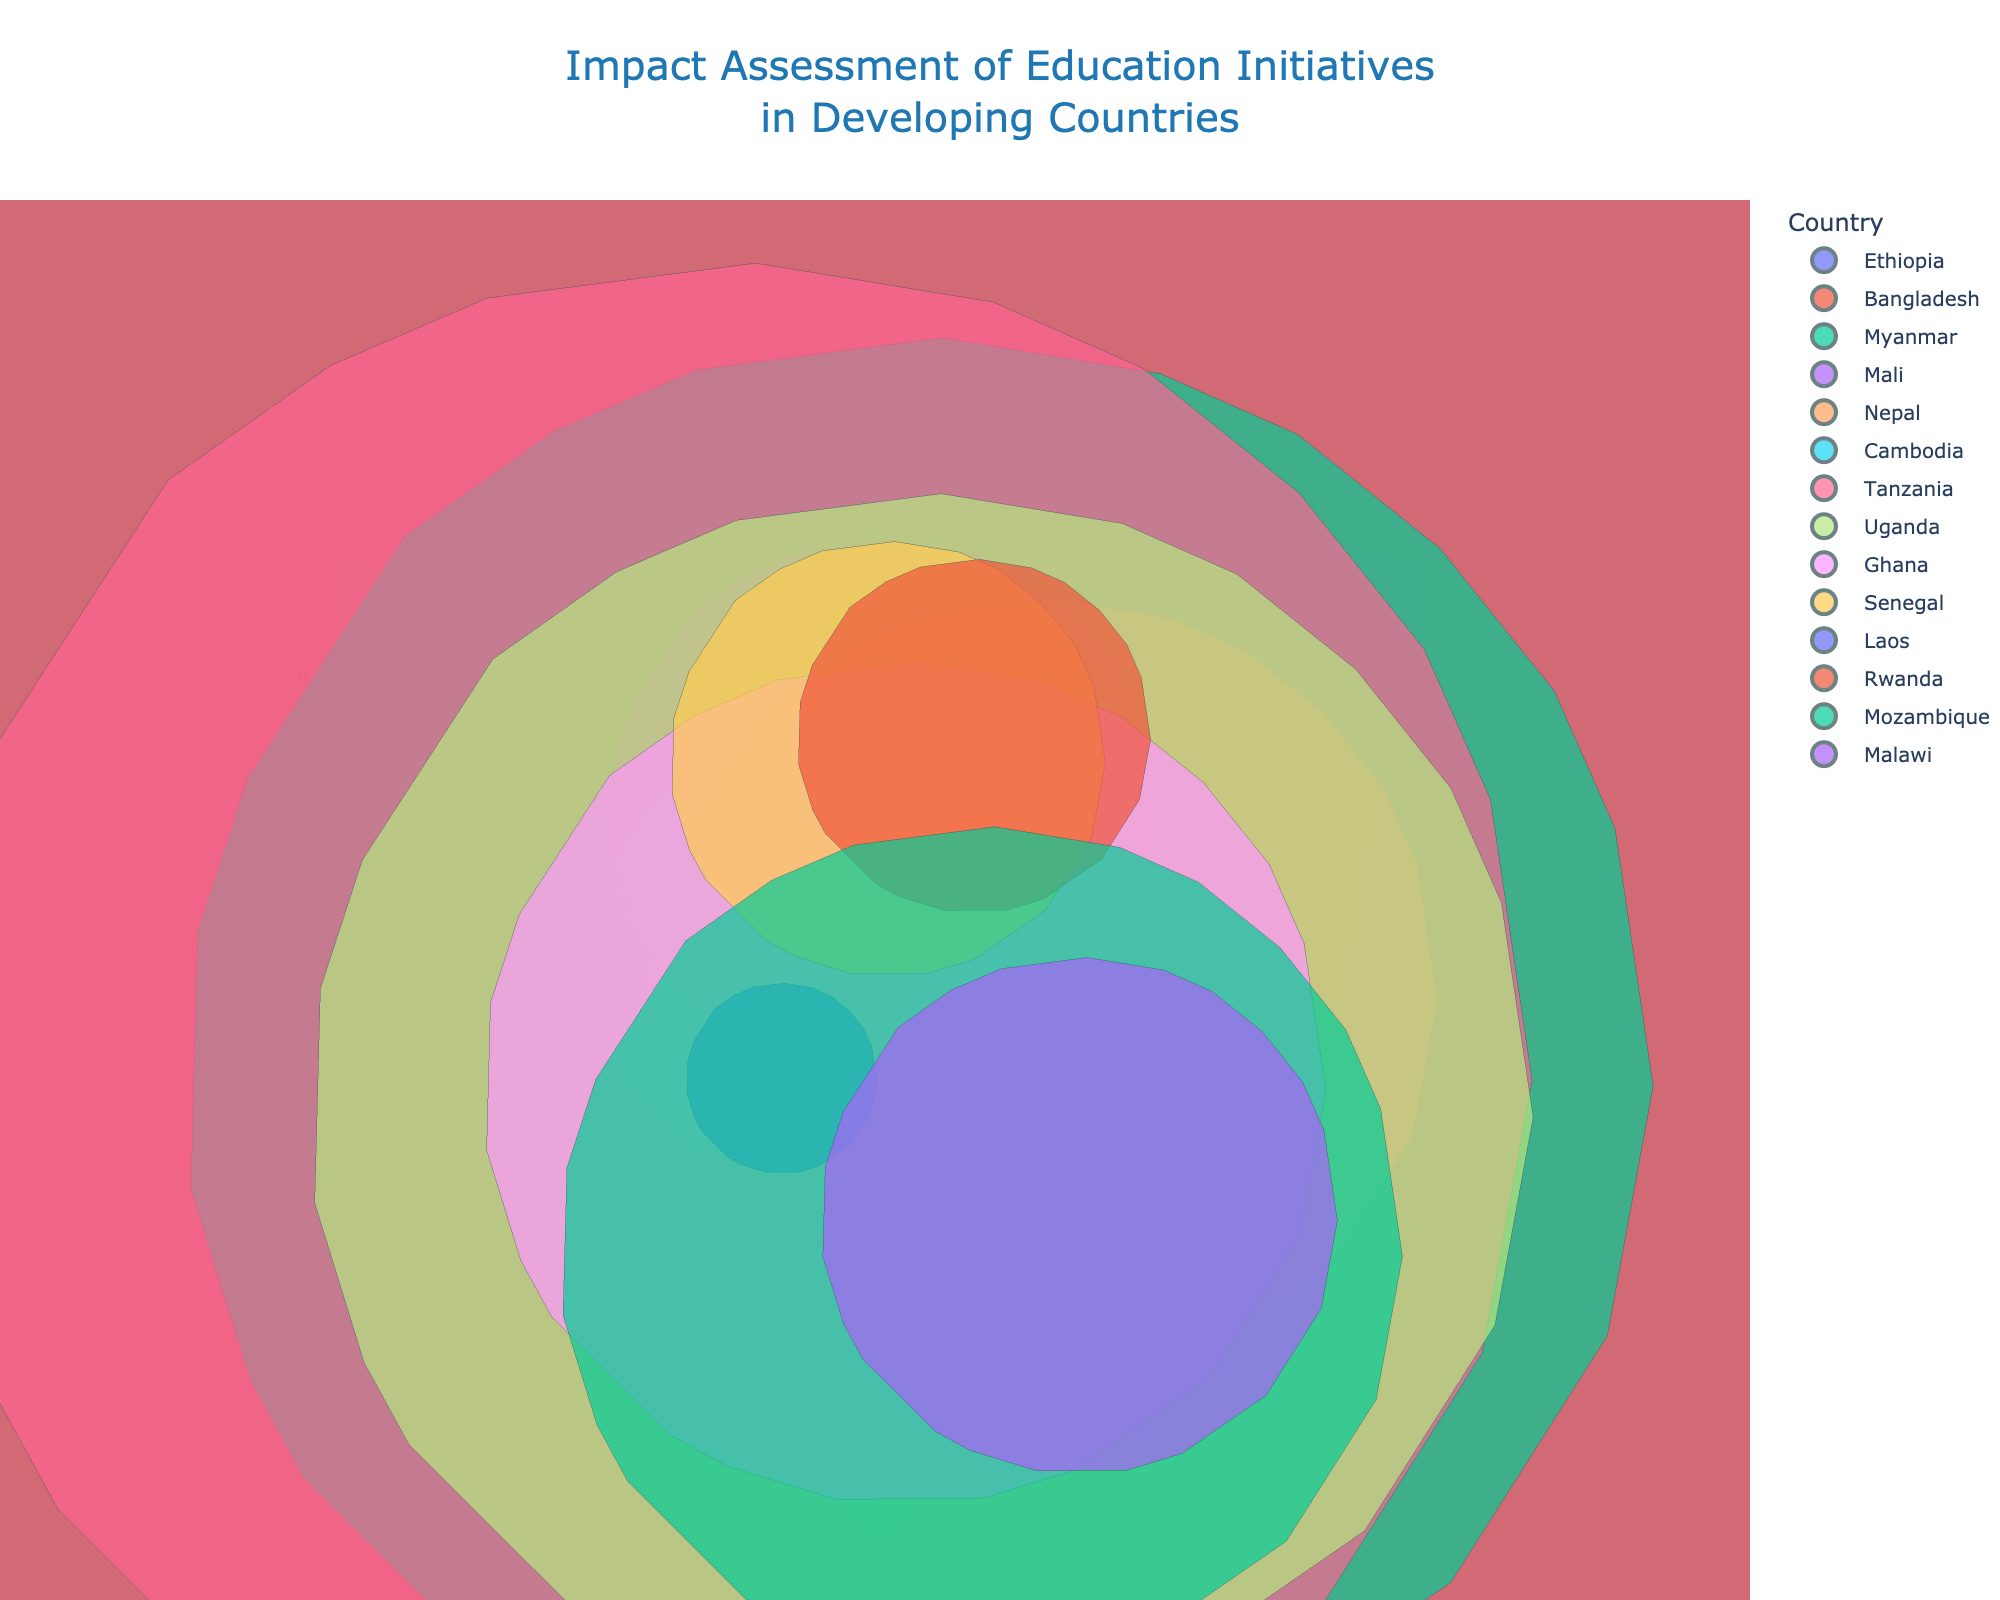What is the title of the 3D bubble chart? The title is at the top of the chart and summarizes the purpose of the visual. It reads "Impact Assessment of Education Initiatives in Developing Countries."
Answer: Impact Assessment of Education Initiatives in Developing Countries Which country has the highest literacy rate? Look at the axis labeled "Literacy Rate (%)" and find the highest point. The country near this point is Laos with a literacy rate of 84.7%.
Answer: Laos Which country has the lowest economic growth rate? Check the axis labeled "Economic Growth (%)" and find the lowest point. The country near this point is Mozambique with an economic growth rate of 3.4%.
Answer: Mozambique How many countries have an enrollment rate higher than 90%? Identify the points above 90% on the "Enrollment Rate (%)" axis. The countries are Bangladesh, Myanmar, Nepal, Uganda, Ghana, Laos, Rwanda, and Malawi. Counting these gives 8 countries.
Answer: 8 What is the economic growth rate for Tanzania? Find the bubble labeled "Tanzania" and look at its position on the "Economic Growth (%)" axis. The economic growth rate is 5.8%.
Answer: 5.8% Which country has the largest bubble and what does it represent? The size of the bubbles represents the population. The largest bubble is for Bangladesh, indicating it has the largest population.
Answer: Bangladesh Compare the literacy rates of Cambodia and Ghana. Which is higher, and by how much? Locate the bubbles for Cambodia and Ghana and compare their positions on the "Literacy Rate (%)" axis. Cambodia has a literacy rate of 80.5% and Ghana 79.0%. The difference is 1.5%.
Answer: Cambodia, 1.5% What is the overall trend between literacy rate and economic growth among the countries? Observe the overall pattern of the bubbles along the "Literacy Rate (%)" and "Economic Growth (%)" axes. Generally, higher literacy rates are associated with higher economic growth rates.
Answer: Higher literacy rates, higher economic growth rates Which two countries have the most similar economic growth rates? Look for countries with bubbles close together along the "Economic Growth (%)" axis. Myanmar and Ghana both show around 6.4-6.5% economic growth.
Answer: Myanmar and Ghana For countries with a population less than 20 million, which has the highest economic growth rate? Identify bubbles representing countries with populations less than 20 million (size of bubbles) and check their economic growth rates. Rwanda, with a population of 13 million, has the highest economic growth rate at 8.6%.
Answer: Rwanda 